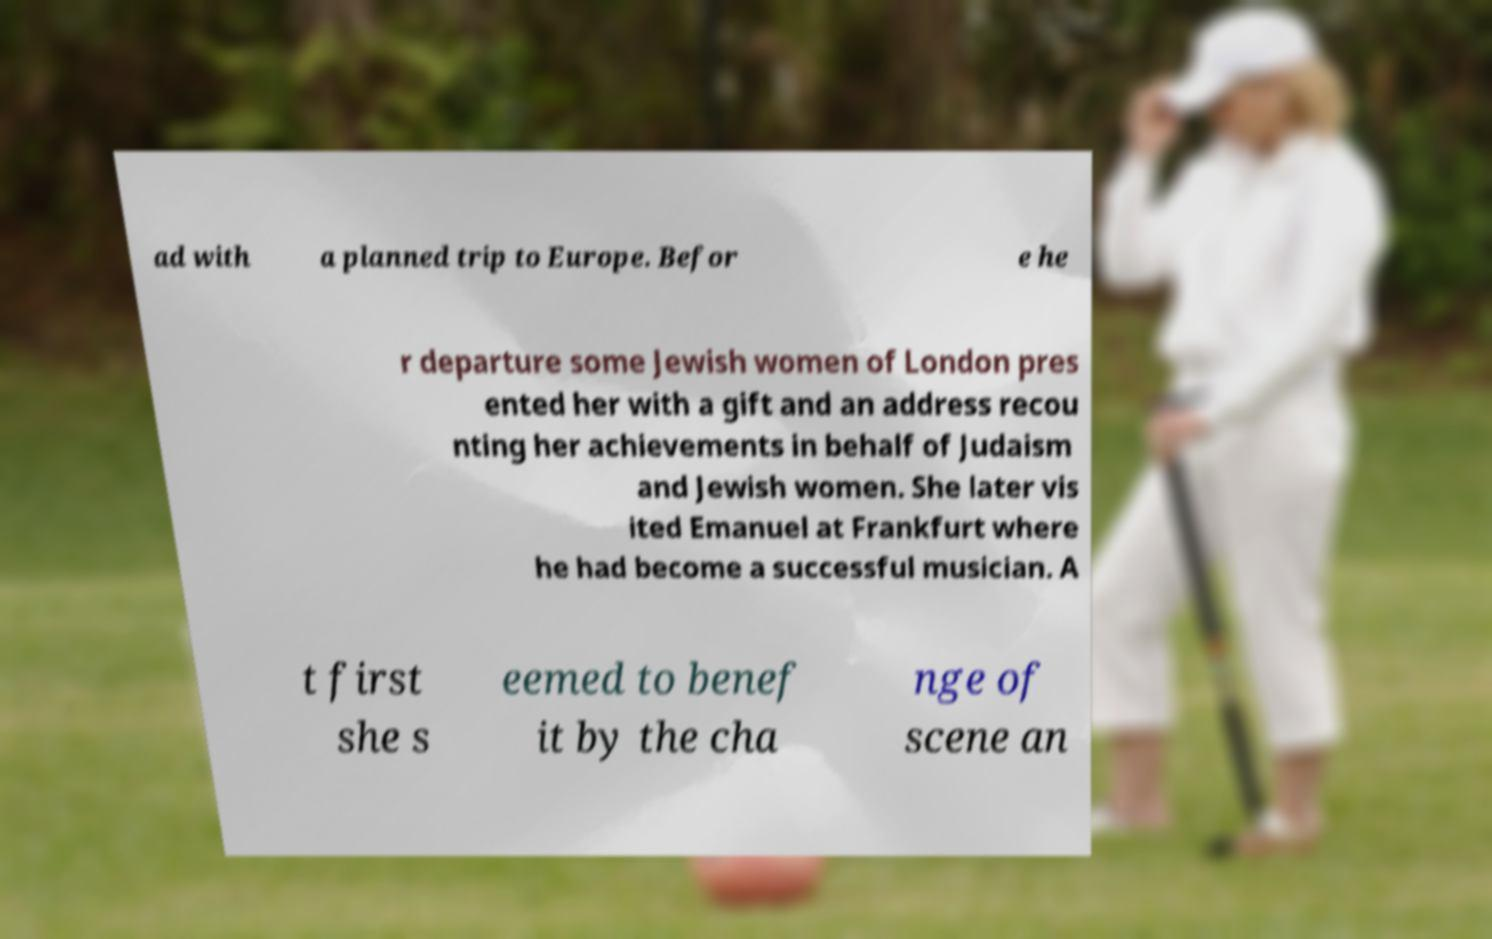Please identify and transcribe the text found in this image. ad with a planned trip to Europe. Befor e he r departure some Jewish women of London pres ented her with a gift and an address recou nting her achievements in behalf of Judaism and Jewish women. She later vis ited Emanuel at Frankfurt where he had become a successful musician. A t first she s eemed to benef it by the cha nge of scene an 